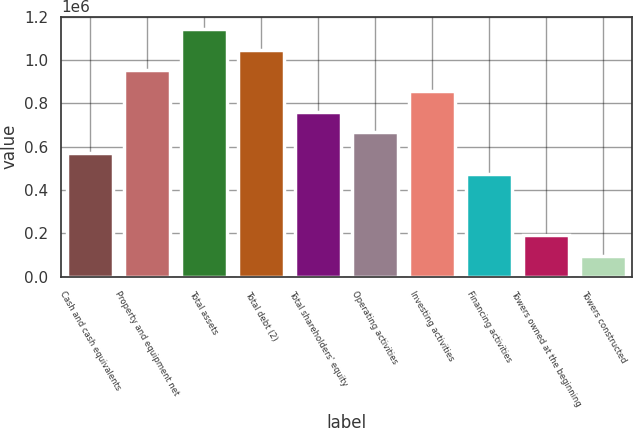Convert chart to OTSL. <chart><loc_0><loc_0><loc_500><loc_500><bar_chart><fcel>Cash and cash equivalents<fcel>Property and equipment net<fcel>Total assets<fcel>Total debt (2)<fcel>Total shareholders' equity<fcel>Operating activities<fcel>Investing activities<fcel>Financing activities<fcel>Towers owned at the beginning<fcel>Towers constructed<nl><fcel>571524<fcel>952536<fcel>1.14304e+06<fcel>1.04779e+06<fcel>762030<fcel>666777<fcel>857283<fcel>476271<fcel>190512<fcel>95259<nl></chart> 